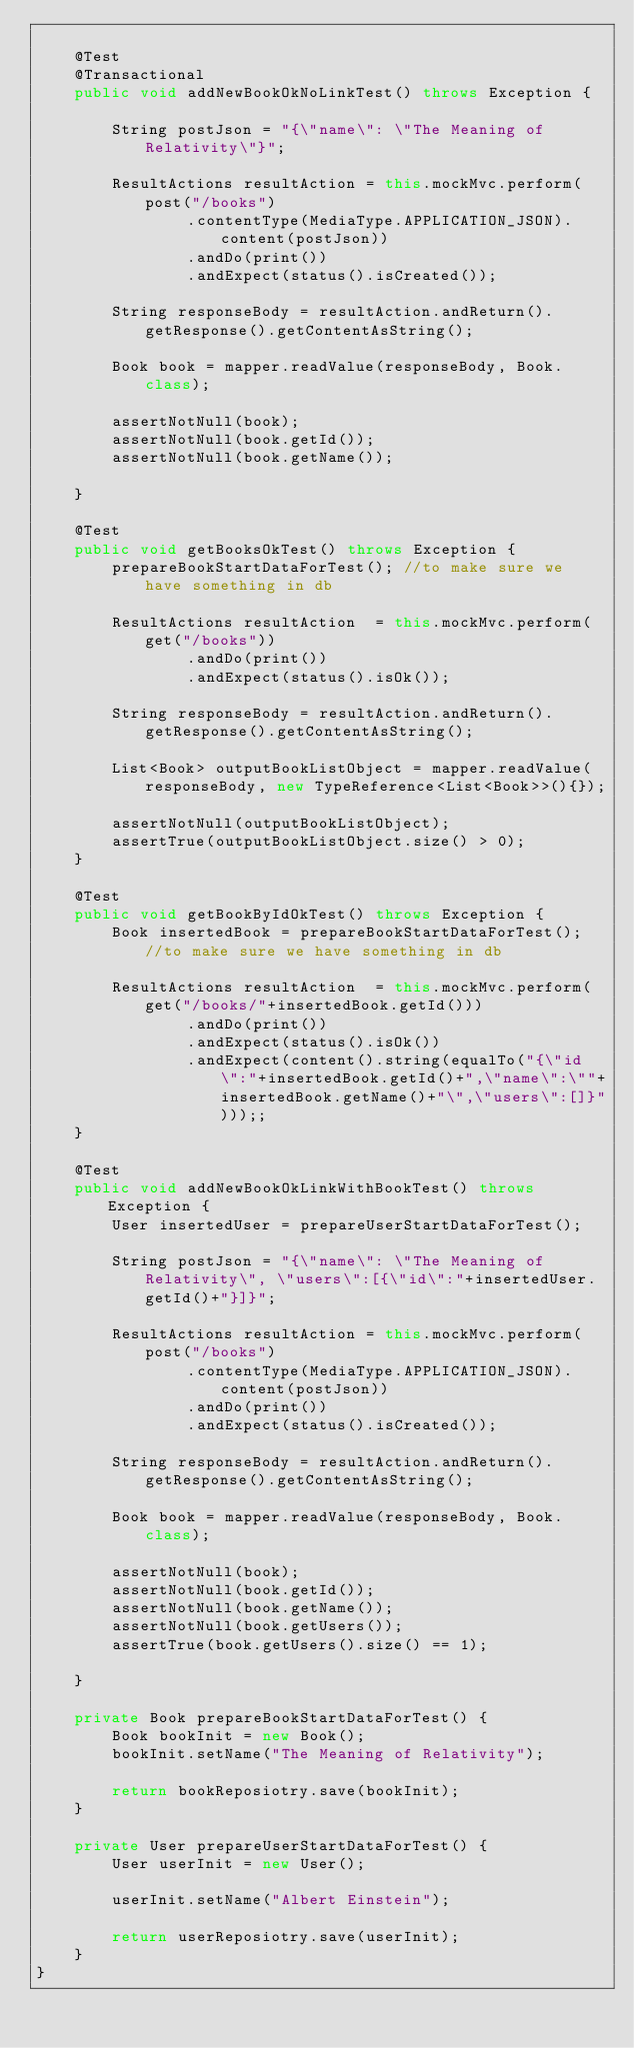<code> <loc_0><loc_0><loc_500><loc_500><_Java_>	
	@Test
	@Transactional
	public void addNewBookOkNoLinkTest() throws Exception {
		
		String postJson = "{\"name\": \"The Meaning of Relativity\"}";

		ResultActions resultAction = this.mockMvc.perform(post("/books")
				.contentType(MediaType.APPLICATION_JSON).content(postJson))
				.andDo(print())
				.andExpect(status().isCreated());
		
		String responseBody = resultAction.andReturn().getResponse().getContentAsString();
		
		Book book = mapper.readValue(responseBody, Book.class);
		
		assertNotNull(book);
		assertNotNull(book.getId());
		assertNotNull(book.getName());
		
	}
	
	@Test
	public void getBooksOkTest() throws Exception {
		prepareBookStartDataForTest(); //to make sure we have something in db
		
		ResultActions resultAction  = this.mockMvc.perform(get("/books"))
				.andDo(print())
				.andExpect(status().isOk());
		
		String responseBody = resultAction.andReturn().getResponse().getContentAsString();
		
		List<Book> outputBookListObject = mapper.readValue(responseBody, new TypeReference<List<Book>>(){});
		
		assertNotNull(outputBookListObject);
		assertTrue(outputBookListObject.size() > 0);
	}
	
	@Test
	public void getBookByIdOkTest() throws Exception {
		Book insertedBook = prepareBookStartDataForTest(); //to make sure we have something in db
		
		ResultActions resultAction  = this.mockMvc.perform(get("/books/"+insertedBook.getId()))
				.andDo(print())
				.andExpect(status().isOk())
				.andExpect(content().string(equalTo("{\"id\":"+insertedBook.getId()+",\"name\":\""+insertedBook.getName()+"\",\"users\":[]}")));;
	}
	
	@Test
	public void addNewBookOkLinkWithBookTest() throws Exception {
		User insertedUser = prepareUserStartDataForTest();
		
		String postJson = "{\"name\": \"The Meaning of Relativity\", \"users\":[{\"id\":"+insertedUser.getId()+"}]}";

		ResultActions resultAction = this.mockMvc.perform(post("/books")
				.contentType(MediaType.APPLICATION_JSON).content(postJson))
				.andDo(print())
				.andExpect(status().isCreated());
		
		String responseBody = resultAction.andReturn().getResponse().getContentAsString();
		
		Book book = mapper.readValue(responseBody, Book.class);
		
		assertNotNull(book);
		assertNotNull(book.getId());
		assertNotNull(book.getName());
		assertNotNull(book.getUsers());
		assertTrue(book.getUsers().size() == 1);
		
	}
	
	private Book prepareBookStartDataForTest() {
		Book bookInit = new Book();
		bookInit.setName("The Meaning of Relativity");

		return bookReposiotry.save(bookInit);
	}
	
	private User prepareUserStartDataForTest() {
		User userInit = new User();

		userInit.setName("Albert Einstein");
		
		return userReposiotry.save(userInit);
	}
}
</code> 